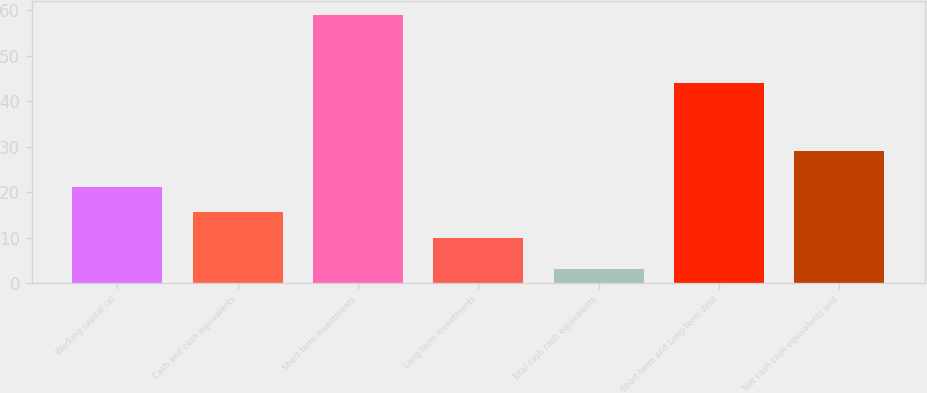Convert chart to OTSL. <chart><loc_0><loc_0><loc_500><loc_500><bar_chart><fcel>Working capital (a)<fcel>Cash and cash equivalents<fcel>Short-term investments<fcel>Long-term investments<fcel>Total cash cash equivalents<fcel>Short-term and Long-term debt<fcel>Net cash cash equivalents and<nl><fcel>21.2<fcel>15.6<fcel>59<fcel>10<fcel>3<fcel>44<fcel>29<nl></chart> 